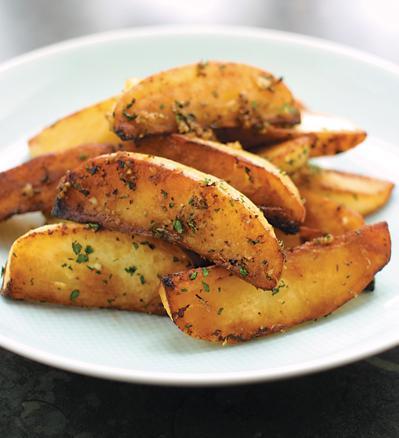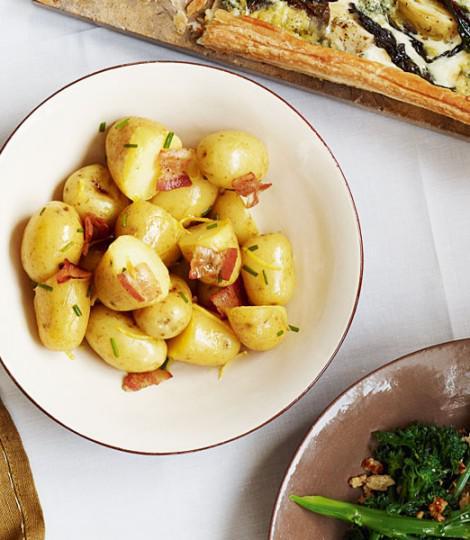The first image is the image on the left, the second image is the image on the right. Considering the images on both sides, is "Both food items are in bowls." valid? Answer yes or no. No. The first image is the image on the left, the second image is the image on the right. For the images displayed, is the sentence "The left image shows a round bowl without handles containing potato sections, and the right image shows a white interiored dish with handles containing sliced potato pieces." factually correct? Answer yes or no. No. 